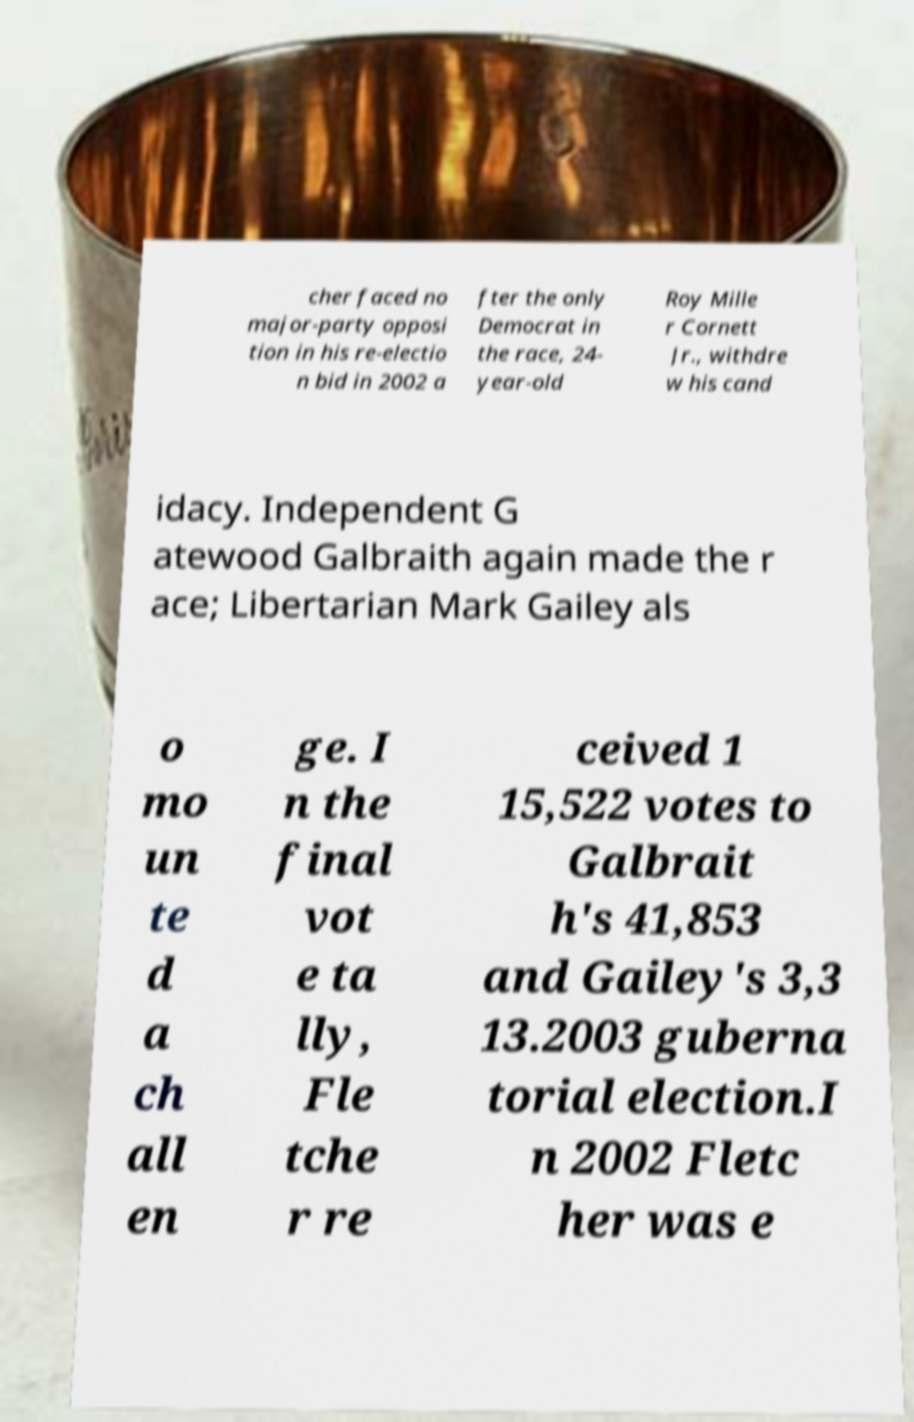Could you extract and type out the text from this image? cher faced no major-party opposi tion in his re-electio n bid in 2002 a fter the only Democrat in the race, 24- year-old Roy Mille r Cornett Jr., withdre w his cand idacy. Independent G atewood Galbraith again made the r ace; Libertarian Mark Gailey als o mo un te d a ch all en ge. I n the final vot e ta lly, Fle tche r re ceived 1 15,522 votes to Galbrait h's 41,853 and Gailey's 3,3 13.2003 guberna torial election.I n 2002 Fletc her was e 